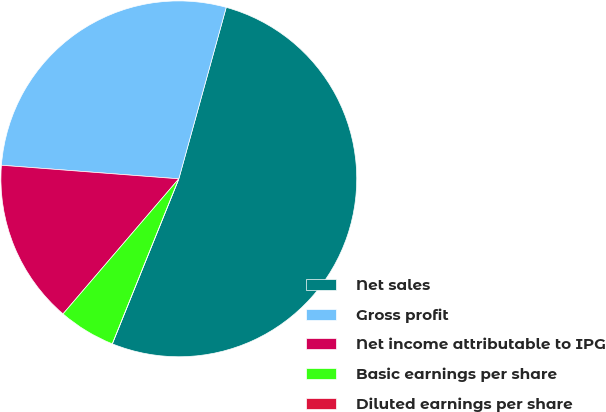Convert chart. <chart><loc_0><loc_0><loc_500><loc_500><pie_chart><fcel>Net sales<fcel>Gross profit<fcel>Net income attributable to IPG<fcel>Basic earnings per share<fcel>Diluted earnings per share<nl><fcel>51.81%<fcel>28.08%<fcel>14.94%<fcel>5.18%<fcel>0.0%<nl></chart> 